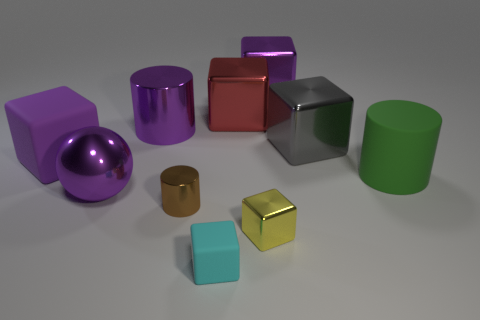What number of yellow metallic objects are in front of the large gray cube?
Keep it short and to the point. 1. The green matte thing has what size?
Give a very brief answer. Large. Are the big thing in front of the big green matte cylinder and the big purple thing that is right of the tiny rubber thing made of the same material?
Offer a terse response. Yes. Is there a small matte cube that has the same color as the shiny ball?
Make the answer very short. No. What is the color of the sphere that is the same size as the purple cylinder?
Your answer should be compact. Purple. There is a small cube on the right side of the tiny matte thing; does it have the same color as the matte cylinder?
Make the answer very short. No. Is there a small brown cylinder that has the same material as the large green thing?
Offer a terse response. No. Is the number of green objects on the left side of the cyan block less than the number of large cyan rubber balls?
Your response must be concise. No. There is a shiny object behind the red metallic cube; is it the same size as the yellow object?
Keep it short and to the point. No. How many other tiny objects are the same shape as the brown metallic thing?
Keep it short and to the point. 0. 